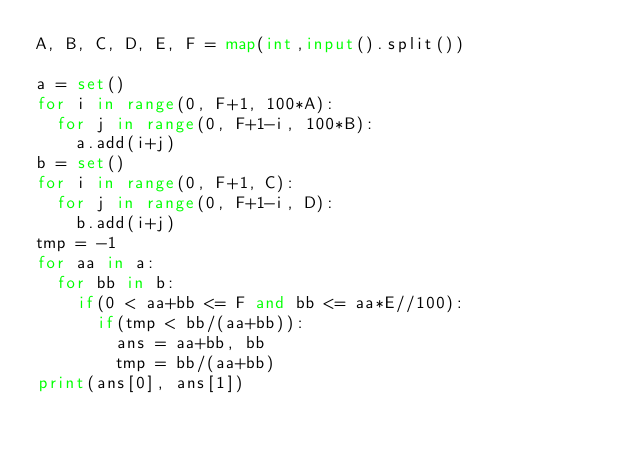<code> <loc_0><loc_0><loc_500><loc_500><_Python_>A, B, C, D, E, F = map(int,input().split())

a = set()
for i in range(0, F+1, 100*A):
  for j in range(0, F+1-i, 100*B):
    a.add(i+j)
b = set()
for i in range(0, F+1, C):
  for j in range(0, F+1-i, D):
    b.add(i+j)
tmp = -1
for aa in a:
  for bb in b:
    if(0 < aa+bb <= F and bb <= aa*E//100):
      if(tmp < bb/(aa+bb)):
        ans = aa+bb, bb
        tmp = bb/(aa+bb)
print(ans[0], ans[1])</code> 